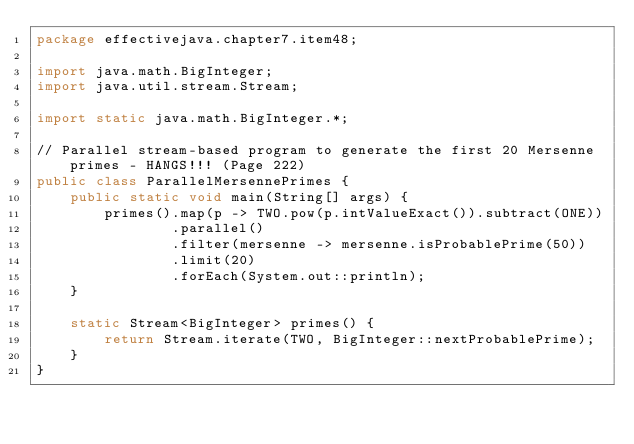Convert code to text. <code><loc_0><loc_0><loc_500><loc_500><_Java_>package effectivejava.chapter7.item48;

import java.math.BigInteger;
import java.util.stream.Stream;

import static java.math.BigInteger.*;

// Parallel stream-based program to generate the first 20 Mersenne primes - HANGS!!! (Page 222)
public class ParallelMersennePrimes {
    public static void main(String[] args) {
        primes().map(p -> TWO.pow(p.intValueExact()).subtract(ONE))
                .parallel()
                .filter(mersenne -> mersenne.isProbablePrime(50))
                .limit(20)
                .forEach(System.out::println);
    }

    static Stream<BigInteger> primes() {
        return Stream.iterate(TWO, BigInteger::nextProbablePrime);
    }
}
</code> 